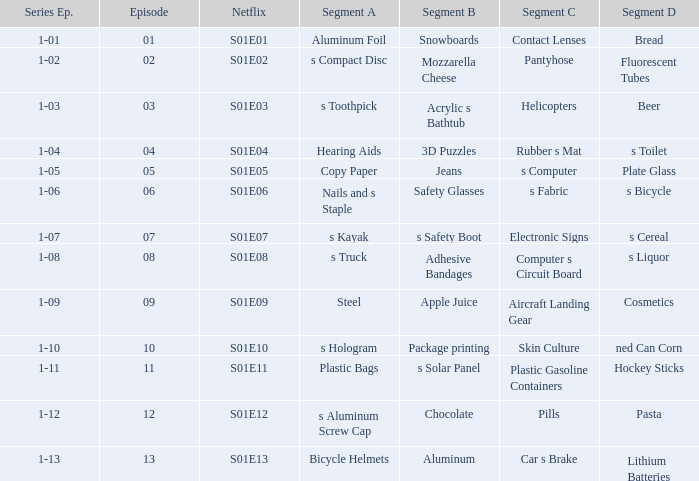What is the Netflix number having a segment D, of NED can corn? S01E10. 